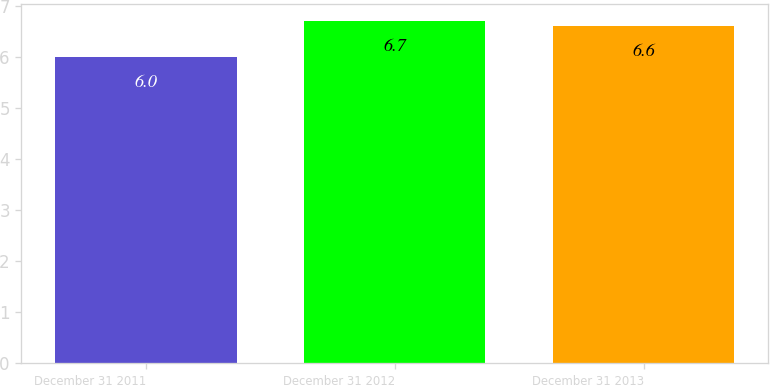Convert chart to OTSL. <chart><loc_0><loc_0><loc_500><loc_500><bar_chart><fcel>December 31 2011<fcel>December 31 2012<fcel>December 31 2013<nl><fcel>6<fcel>6.7<fcel>6.6<nl></chart> 